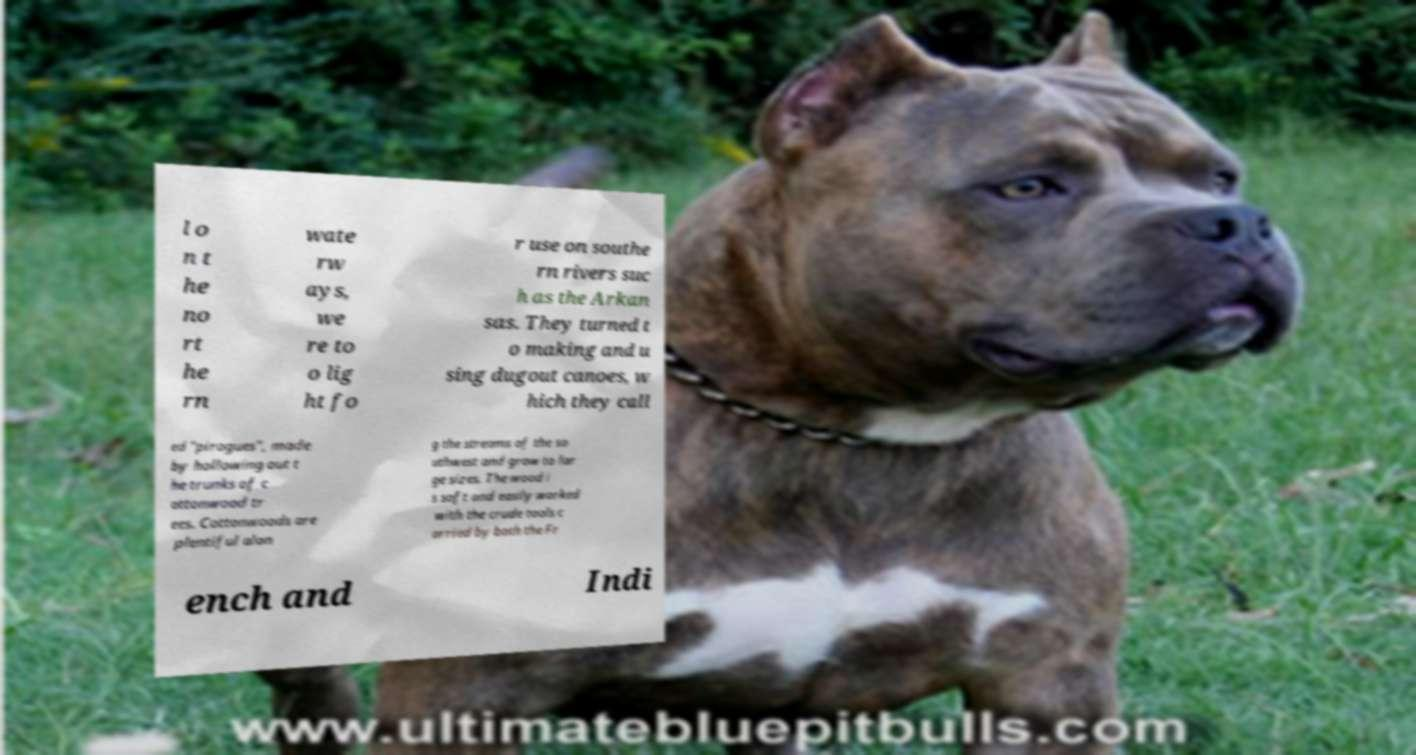For documentation purposes, I need the text within this image transcribed. Could you provide that? l o n t he no rt he rn wate rw ays, we re to o lig ht fo r use on southe rn rivers suc h as the Arkan sas. They turned t o making and u sing dugout canoes, w hich they call ed "pirogues", made by hollowing out t he trunks of c ottonwood tr ees. Cottonwoods are plentiful alon g the streams of the so uthwest and grow to lar ge sizes. The wood i s soft and easily worked with the crude tools c arried by both the Fr ench and Indi 